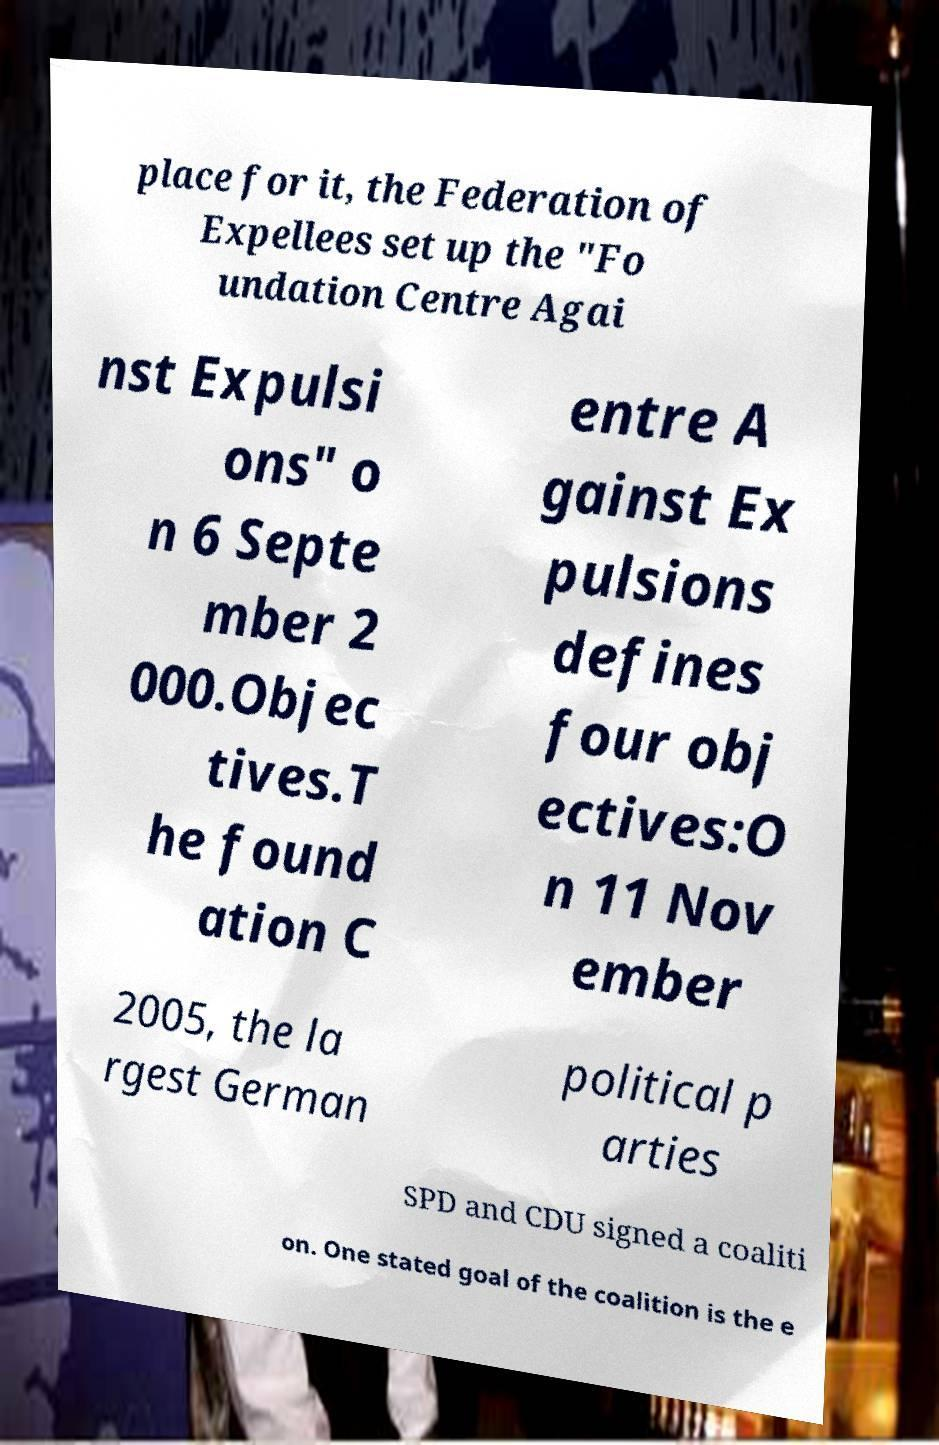There's text embedded in this image that I need extracted. Can you transcribe it verbatim? place for it, the Federation of Expellees set up the "Fo undation Centre Agai nst Expulsi ons" o n 6 Septe mber 2 000.Objec tives.T he found ation C entre A gainst Ex pulsions defines four obj ectives:O n 11 Nov ember 2005, the la rgest German political p arties SPD and CDU signed a coaliti on. One stated goal of the coalition is the e 